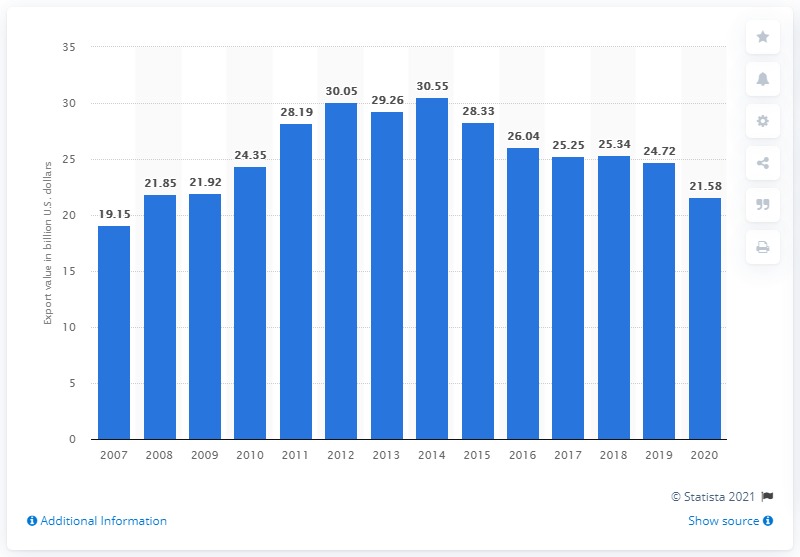Specify some key components in this picture. In 2020, the value of U.S. industrial engine exports was 21.58. 